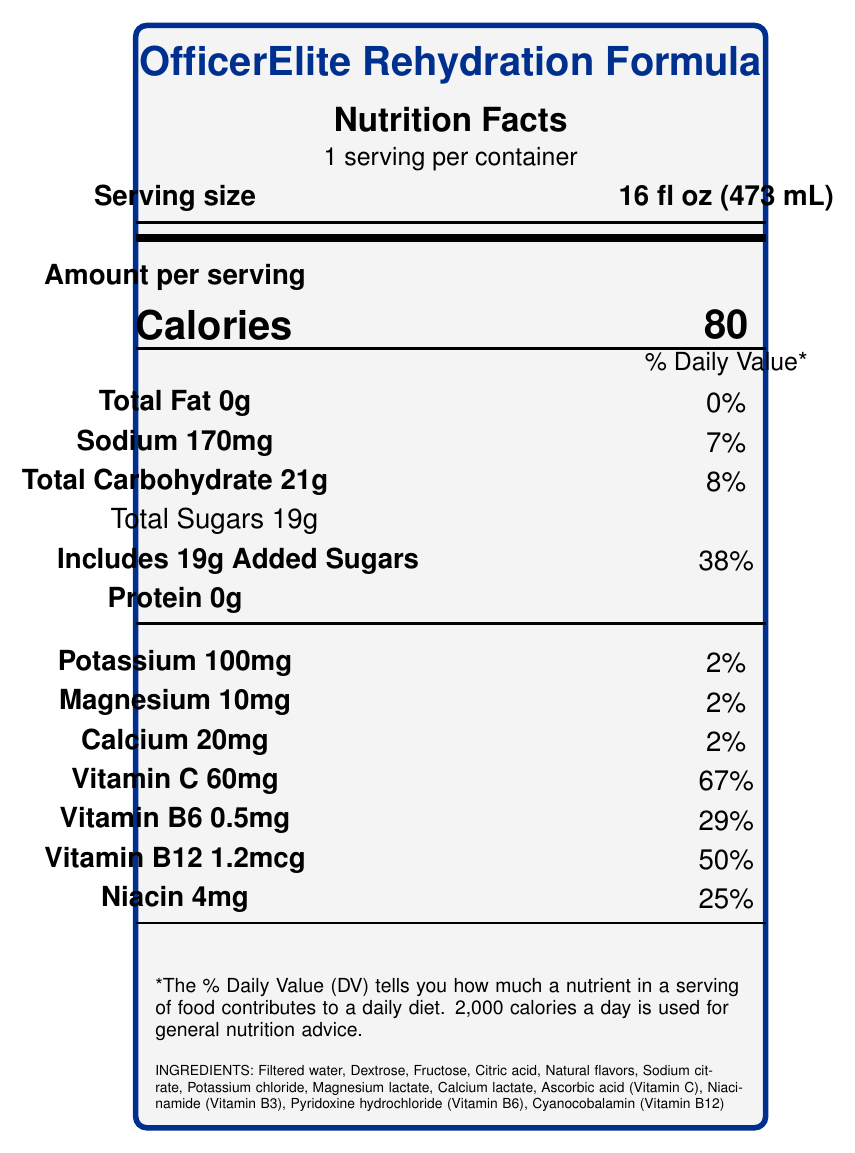What is the serving size of OfficerElite Rehydration Formula? The serving size is listed as "16 fl oz (473 mL)" on the document.
Answer: 16 fl oz (473 mL) How many calories are in one serving of the OfficerElite Rehydration Formula? The document states that there are 80 calories per serving.
Answer: 80 calories What percentage of the daily value of Vitamin C does one serving of this product provide? According to the document, one serving provides 67% of the daily value for Vitamin C.
Answer: 67% Name three electrolytes mentioned in the ingredient list. The ingredients list includes Sodium citrate, Potassium chloride, and Magnesium lactate.
Answer: Sodium, Potassium, Magnesium How much added sugar is in one serving of the product? The document specifies that the total sugars amount is 19g, all of which are added sugars.
Answer: 19g What is the daily value percentage of total carbohydrates in one serving? The document says the total carbohydrate daily value percentage is 8%.
Answer: 8% Does the OfficerElite Rehydration Formula contain any protein? The document lists 0g of protein.
Answer: No Select the correct manufacturer of the product. A. Global Health Supply Inc. B. Defense Nutrition Systems, Inc. C. Military Nutrition Corporation The document lists "Defense Nutrition Systems, Inc." as the manufacturer.
Answer: B Which vitamin has the highest daily value percentage per serving? A. Vitamin B6 B. Vitamin B12 C. Vitamin C Vitamin C has the highest daily value percentage at 67%, compared to Vitamin B6 at 29% and Vitamin B12 at 50%.
Answer: C Is the OfficerElite Rehydration Formula designed for regular civilian use? The product is designed for officers in high-stress environments and specifically mentioned as formulated for intense physical activity or prolonged exposure to challenging conditions.
Answer: No Summarize the main purpose of the OfficerElite Rehydration Formula. The document describes it as a specially formulated electrolyte drink designed to rapidly replenish fluids and essential nutrients during intense physical activity or exposure to high-stress environments for military officers.
Answer: The OfficerElite Rehydration Formula is specially formulated to quickly replenish fluids and essential nutrients lost during intense physical activity or challenging conditions for officers. What is the potassium content in one serving? The document shows that one serving contains 100mg of potassium.
Answer: 100mg Can the exact number of calories from fat in this product be determined based on the information provided? The document lists total fat as 0g but does not directly specify the calories from fat.
Answer: No Is the OfficerElite Rehydration Formula NSF Certified for Sport? The product certifications listed include "NSF Certified for Sport".
Answer: Yes Based on the serving size, calculate the total carbohydrate content in grams for two servings. Since one serving has 21g of carbohydrates, two servings would have 21g x 2 = 42g.
Answer: 42g What facility-related allergen information is provided for this product? The allergen info section states that the product is produced in a facility that processes milk and soy.
Answer: Produced in a facility that processes milk and soy. 